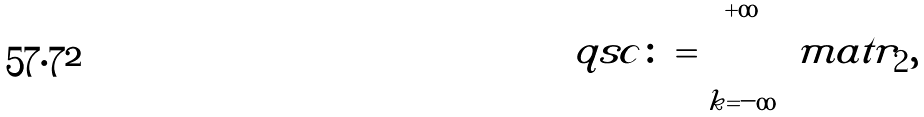<formula> <loc_0><loc_0><loc_500><loc_500>\ q s c \colon = \bigotimes _ { k = - \infty } ^ { + \infty } \ m a t r _ { 2 } ,</formula> 